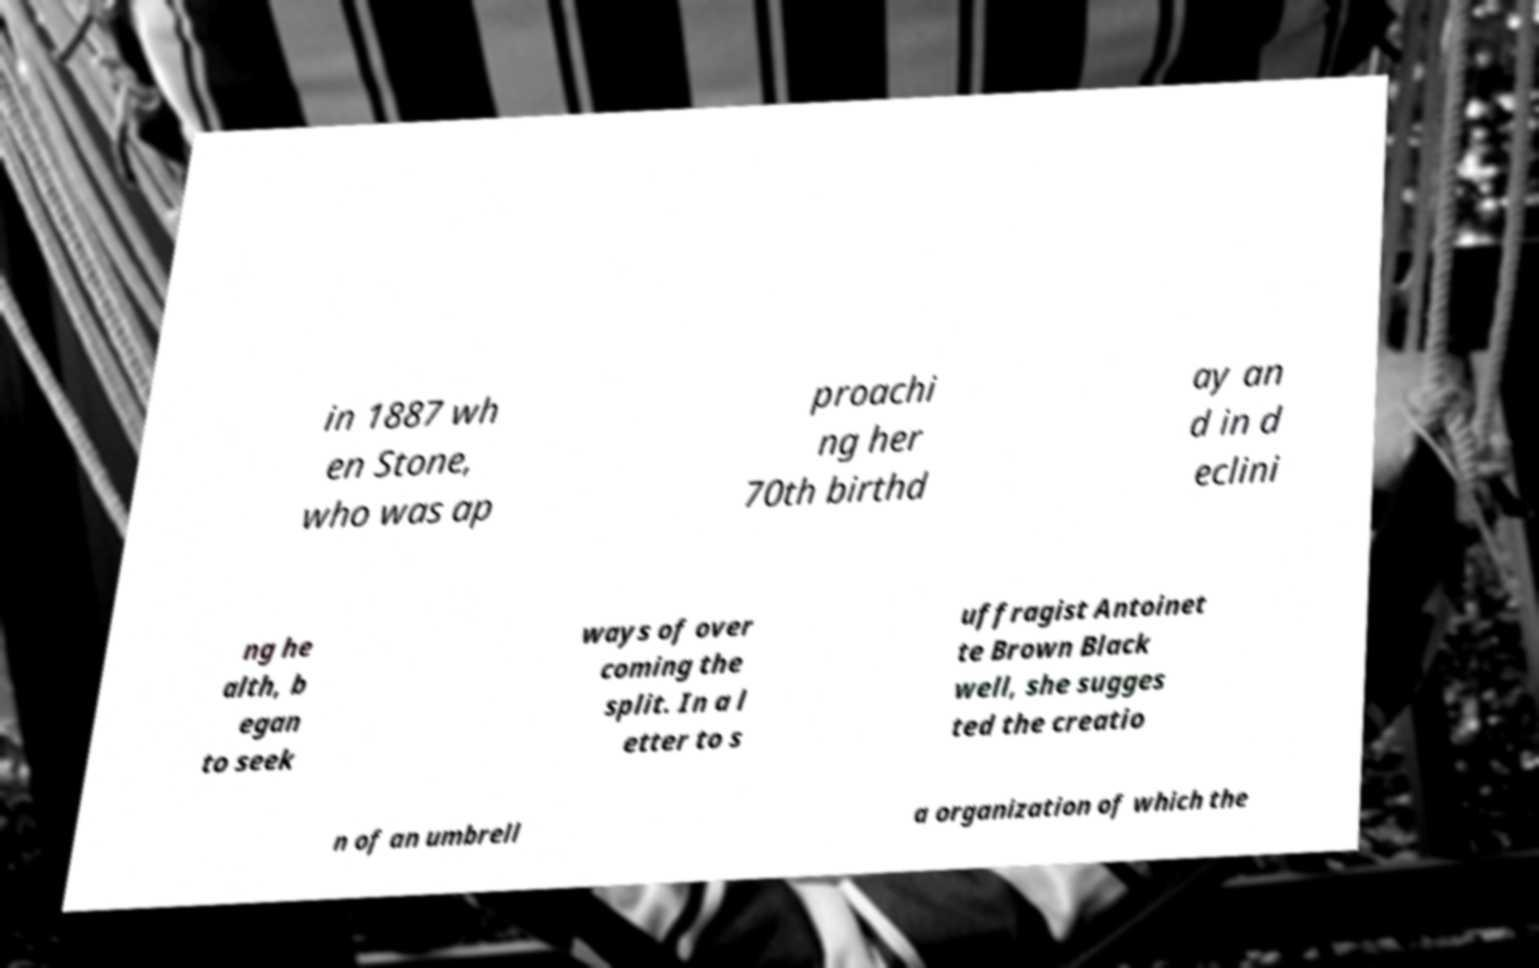What messages or text are displayed in this image? I need them in a readable, typed format. in 1887 wh en Stone, who was ap proachi ng her 70th birthd ay an d in d eclini ng he alth, b egan to seek ways of over coming the split. In a l etter to s uffragist Antoinet te Brown Black well, she sugges ted the creatio n of an umbrell a organization of which the 